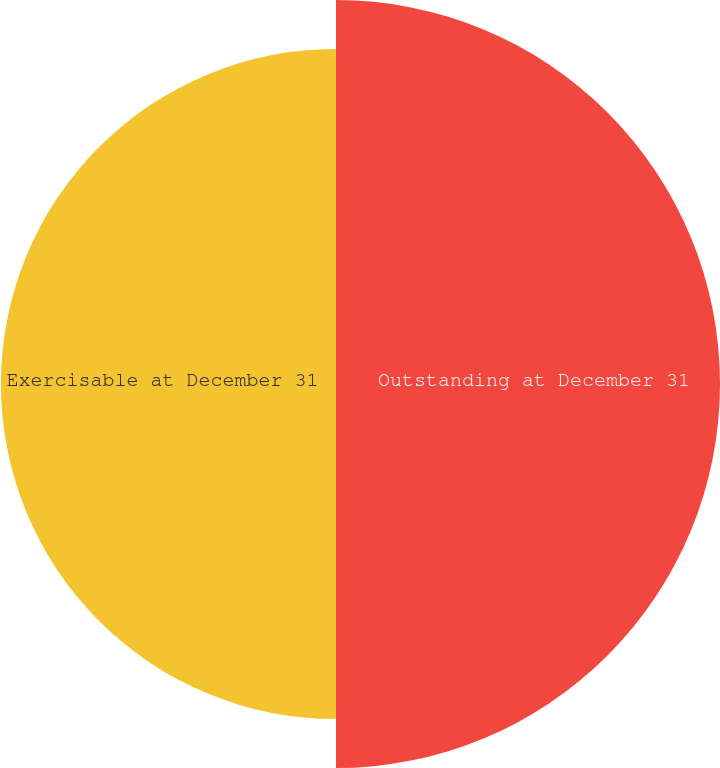<chart> <loc_0><loc_0><loc_500><loc_500><pie_chart><fcel>Outstanding at December 31<fcel>Exercisable at December 31<nl><fcel>53.4%<fcel>46.6%<nl></chart> 